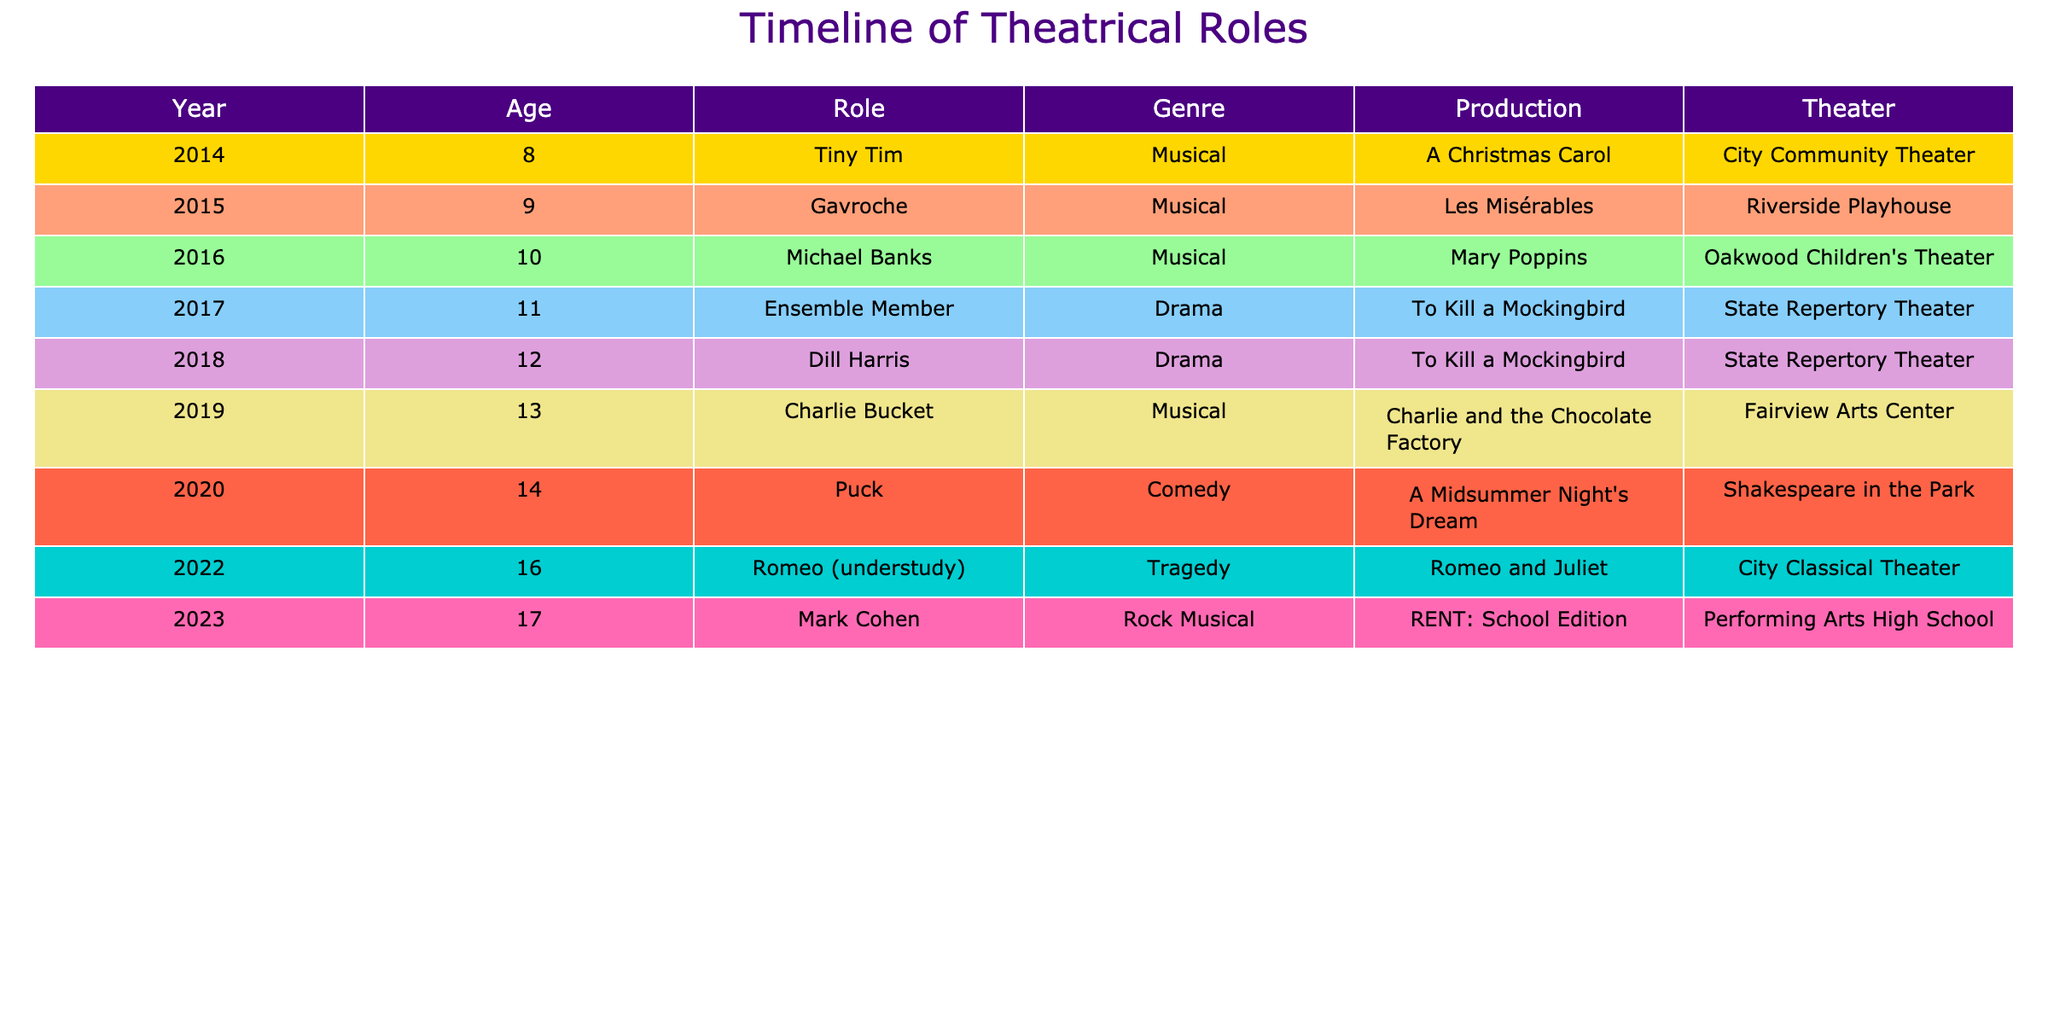What role did you perform in 2019? In the year 2019, the role listed in the table is "Charlie Bucket."
Answer: Charlie Bucket Which genre had the most roles played in the given timeline? By reviewing the table, there are four Musical roles (Tiny Tim, Gavroche, Michael Banks, and Charlie Bucket), two Drama roles (Ensemble Member and Dill Harris), one Comedy role (Puck), one Tragedy role (Romeo), and one Rock Musical role (Mark Cohen). Thus, the Musical genre has the most roles played.
Answer: Musical How many total roles did you play in Drama? Looking at the table, I played two roles in the Drama genre: "Ensemble Member" and "Dill Harris." Therefore, the total number of drama roles I played is 2.
Answer: 2 Did you ever play a role in a Rock Musical? The table shows that in 2023, I played the role of "Mark Cohen" in the Rock Musical genre. Therefore, the answer is yes.
Answer: Yes What was the age difference between the first and last role played? The first role obtained was at age 8 in 2014, while the last role was at age 17 in 2023. The age difference is 17 - 8 = 9 years.
Answer: 9 years How many roles were played in total from 2014 to 2023? Counting each row in the table shows that there are a total of 10 roles listed from 2014 to 2023.
Answer: 10 roles What is the average age at which roles were performed? To calculate the average age, sum the ages (8 + 9 + 10 + 11 + 12 + 13 + 14 + 16 + 17 = 120) and divide by the total number of roles (10). The average age is 120/10 = 12.
Answer: 12 Which production was the first Musical role played? According to the table, the first Musical role was "Tiny Tim" in the production "A Christmas Carol" in 2014.
Answer: A Christmas Carol 